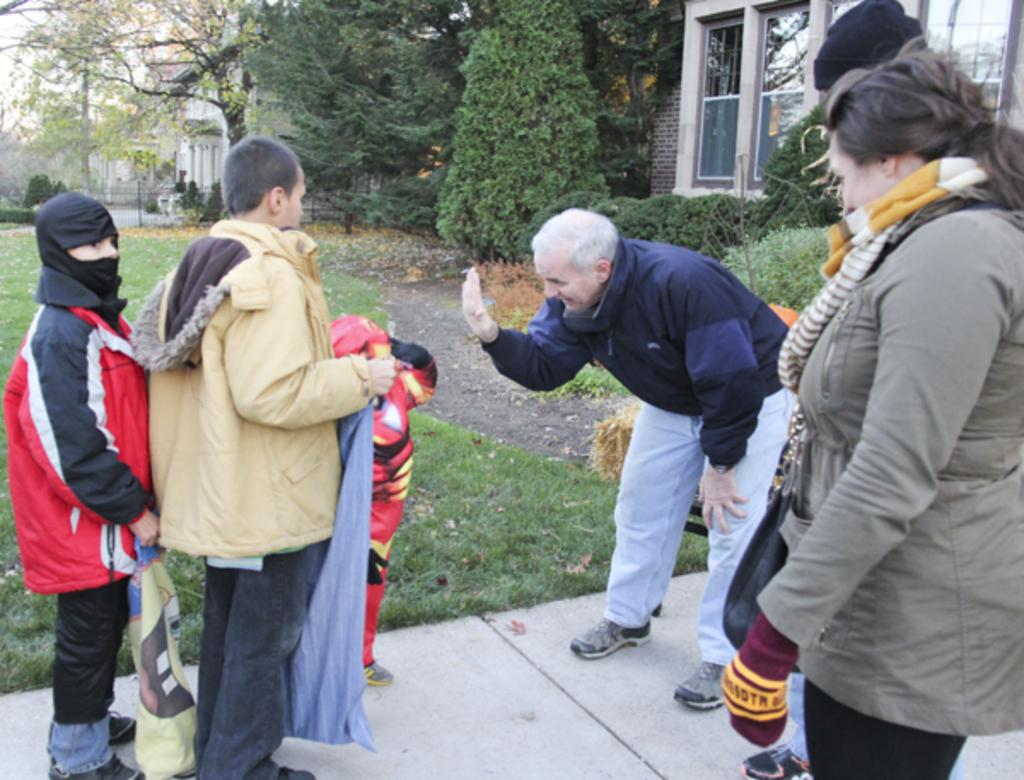What are the people in the image doing? The people in the image are standing on the walkway. What can be seen in the background of the image? In the background, there is grass, trees, plants, houses, walls, pillars, glass windows, and a grill. The sky is also visible. Can you describe the natural elements in the background? The natural elements in the background include grass, trees, and plants. What date is circled on the calendar in the image? There is no calendar present in the image. What page is the person reading in the image? There is no person reading a page in the image. 